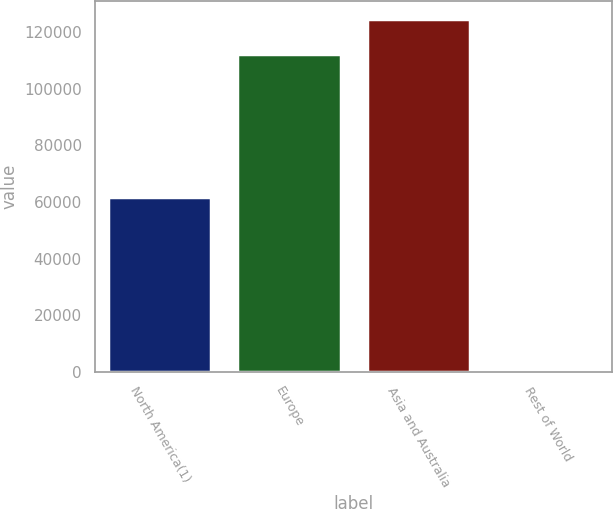<chart> <loc_0><loc_0><loc_500><loc_500><bar_chart><fcel>North America(1)<fcel>Europe<fcel>Asia and Australia<fcel>Rest of World<nl><fcel>61706<fcel>112456<fcel>124797<fcel>840<nl></chart> 